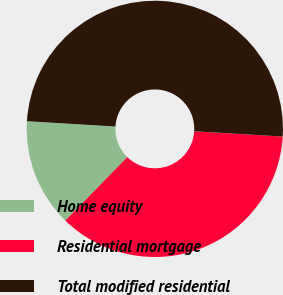Convert chart. <chart><loc_0><loc_0><loc_500><loc_500><pie_chart><fcel>Home equity<fcel>Residential mortgage<fcel>Total modified residential<nl><fcel>13.65%<fcel>36.35%<fcel>50.0%<nl></chart> 